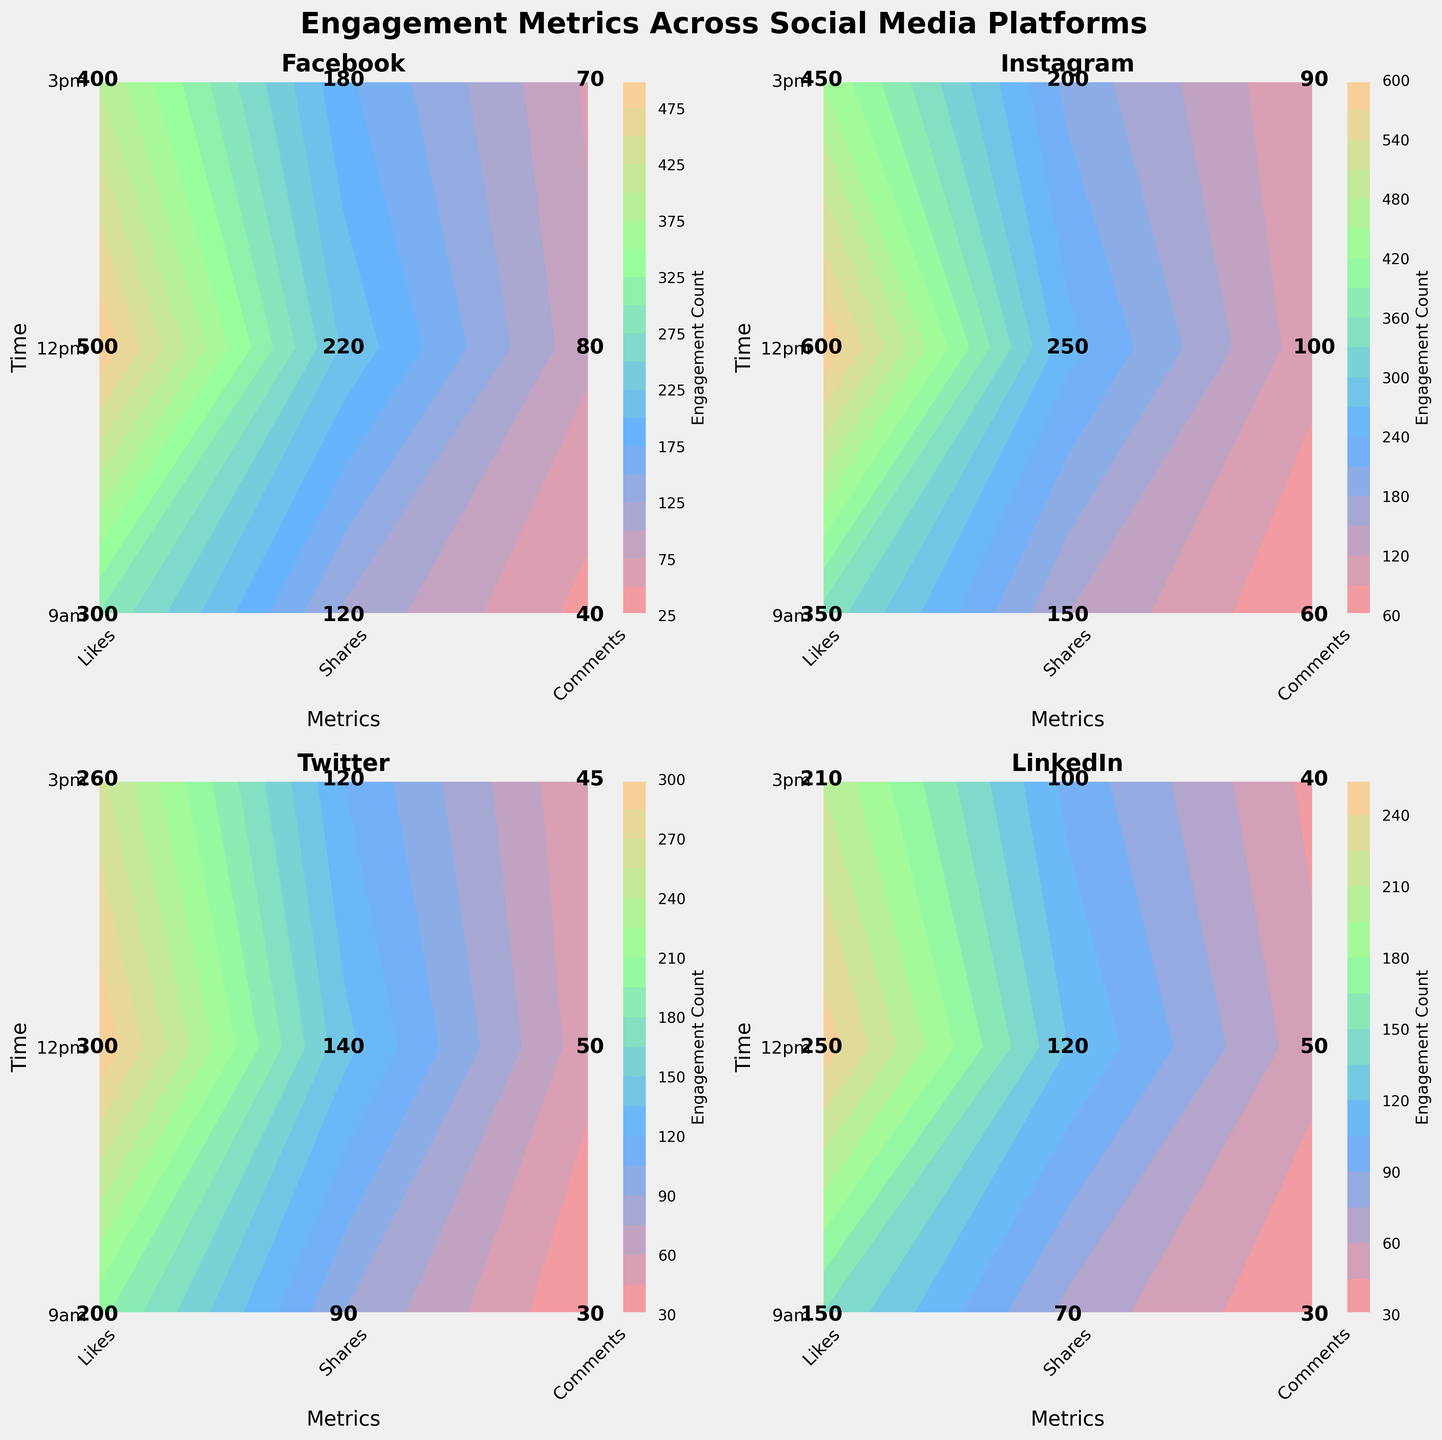What is the title of the figure? The title is displayed at the top of the figure in large, bold font. It reads "Engagement Metrics Across Social Media Platforms".
Answer: Engagement Metrics Across Social Media Platforms What is the highest number of likes at 12pm on Instagram according to the contour plot? By looking at the Instagram contour plot and finding the point on the X-axis (representing Metrics) for 'Likes' at the Y-axis point '12pm', you will see the label 600.
Answer: 600 How do the engagement metrics at 9am compare between Facebook and LinkedIn? At 9am for Facebook, the contour plot shows 300 likes, 120 shares, and 40 comments. For LinkedIn, the contour plot shows 150 likes, 70 shares, and 30 comments. Comparing these values, Facebook has higher engagement across all metrics.
Answer: Facebook has higher engagement Which social media platform shows the highest number of shares at 3pm? Looking at the contour plots for each platform at 3pm and focusing on the 'Shares' metrics, we see that Instagram has the highest value with 200 shares.
Answer: Instagram What is the average number of comments at 12pm across all platforms? First, identify the number of comments at 12pm for each platform: Facebook (80), Instagram (100), Twitter (50), and LinkedIn (50). Then, sum these values (80 + 100 + 50 + 50 = 280) and divide by the number of platforms (4). The average is 70.
Answer: 70 Which metric shows the greatest increase from 9am to 12pm on Facebook? On Facebook, the number of likes increases from 300 at 9am to 500 at 12pm (+200), shares from 120 to 220 (+100), and comments from 40 to 80 (+40). The greatest increase is in likes.
Answer: Likes How do the likes on Twitter at 9am compare to those at 3pm? On the contour plot for Twitter, the number of likes at 9am is 200, while at 3pm it is 260. Therefore, likes are lower at 9am compared to 3pm.
Answer: Lower at 9am What is the total number of shares at 3pm across all platforms? Adding up the number of shares at 3pm for each platform: Facebook (180), Instagram (200), Twitter (120), and LinkedIn (100) gives a total of 600.
Answer: 600 Which platform has the most comments at 9am? Looking at the contour plots for each platform at 9am and focusing on the 'Comments' metric, Instagram has the highest value with 60 comments.
Answer: Instagram What is the difference in the number of likes between Facebook and Twitter at 12pm? At 12pm, Facebook has 500 likes, while Twitter has 300 likes. The difference is 500 - 300, which equals 200.
Answer: 200 